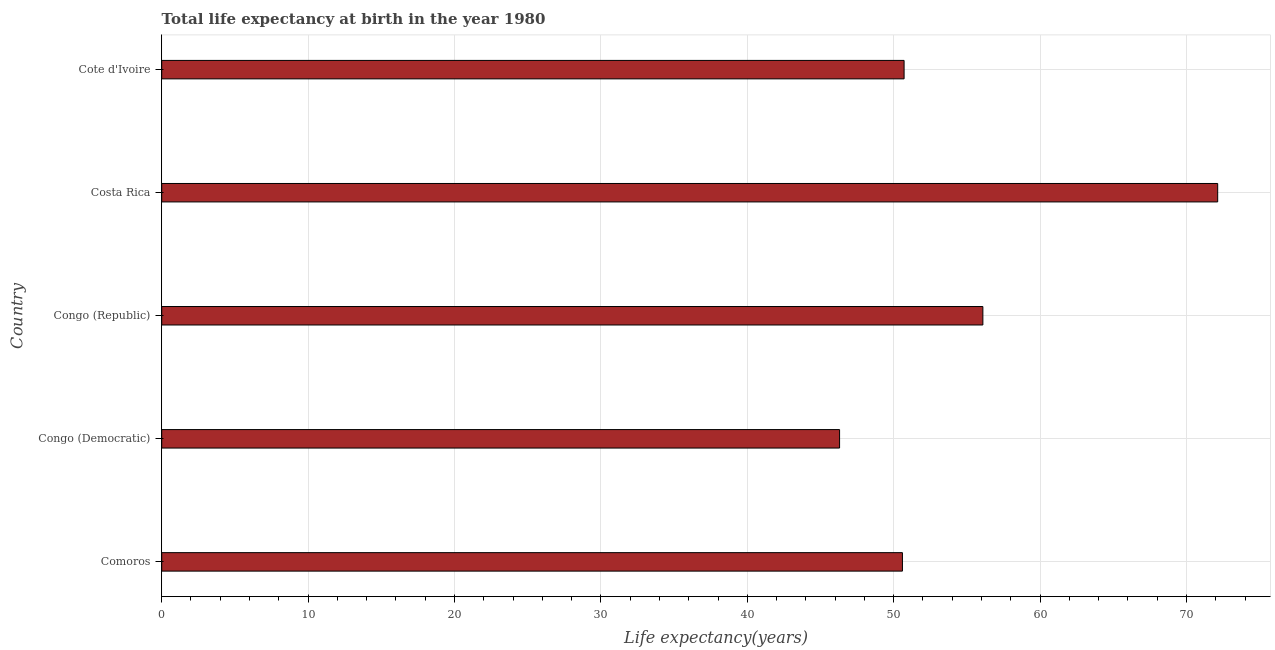What is the title of the graph?
Offer a terse response. Total life expectancy at birth in the year 1980. What is the label or title of the X-axis?
Offer a very short reply. Life expectancy(years). What is the label or title of the Y-axis?
Keep it short and to the point. Country. What is the life expectancy at birth in Congo (Republic)?
Ensure brevity in your answer.  56.09. Across all countries, what is the maximum life expectancy at birth?
Your response must be concise. 72.13. Across all countries, what is the minimum life expectancy at birth?
Offer a very short reply. 46.3. In which country was the life expectancy at birth minimum?
Your answer should be very brief. Congo (Democratic). What is the sum of the life expectancy at birth?
Offer a terse response. 275.83. What is the difference between the life expectancy at birth in Congo (Democratic) and Congo (Republic)?
Give a very brief answer. -9.79. What is the average life expectancy at birth per country?
Give a very brief answer. 55.17. What is the median life expectancy at birth?
Your answer should be very brief. 50.71. In how many countries, is the life expectancy at birth greater than 62 years?
Provide a short and direct response. 1. What is the ratio of the life expectancy at birth in Congo (Democratic) to that in Congo (Republic)?
Your response must be concise. 0.82. Is the life expectancy at birth in Comoros less than that in Congo (Democratic)?
Give a very brief answer. No. What is the difference between the highest and the second highest life expectancy at birth?
Offer a terse response. 16.04. What is the difference between the highest and the lowest life expectancy at birth?
Your answer should be compact. 25.83. In how many countries, is the life expectancy at birth greater than the average life expectancy at birth taken over all countries?
Offer a very short reply. 2. Are all the bars in the graph horizontal?
Your response must be concise. Yes. How many countries are there in the graph?
Offer a very short reply. 5. What is the difference between two consecutive major ticks on the X-axis?
Your answer should be compact. 10. What is the Life expectancy(years) of Comoros?
Offer a terse response. 50.6. What is the Life expectancy(years) in Congo (Democratic)?
Your answer should be very brief. 46.3. What is the Life expectancy(years) in Congo (Republic)?
Provide a succinct answer. 56.09. What is the Life expectancy(years) in Costa Rica?
Ensure brevity in your answer.  72.13. What is the Life expectancy(years) of Cote d'Ivoire?
Make the answer very short. 50.71. What is the difference between the Life expectancy(years) in Comoros and Congo (Democratic)?
Make the answer very short. 4.29. What is the difference between the Life expectancy(years) in Comoros and Congo (Republic)?
Your response must be concise. -5.49. What is the difference between the Life expectancy(years) in Comoros and Costa Rica?
Your response must be concise. -21.53. What is the difference between the Life expectancy(years) in Comoros and Cote d'Ivoire?
Provide a succinct answer. -0.11. What is the difference between the Life expectancy(years) in Congo (Democratic) and Congo (Republic)?
Your response must be concise. -9.79. What is the difference between the Life expectancy(years) in Congo (Democratic) and Costa Rica?
Provide a succinct answer. -25.83. What is the difference between the Life expectancy(years) in Congo (Democratic) and Cote d'Ivoire?
Offer a very short reply. -4.41. What is the difference between the Life expectancy(years) in Congo (Republic) and Costa Rica?
Ensure brevity in your answer.  -16.04. What is the difference between the Life expectancy(years) in Congo (Republic) and Cote d'Ivoire?
Keep it short and to the point. 5.38. What is the difference between the Life expectancy(years) in Costa Rica and Cote d'Ivoire?
Your answer should be very brief. 21.42. What is the ratio of the Life expectancy(years) in Comoros to that in Congo (Democratic)?
Provide a succinct answer. 1.09. What is the ratio of the Life expectancy(years) in Comoros to that in Congo (Republic)?
Keep it short and to the point. 0.9. What is the ratio of the Life expectancy(years) in Comoros to that in Costa Rica?
Your response must be concise. 0.7. What is the ratio of the Life expectancy(years) in Congo (Democratic) to that in Congo (Republic)?
Give a very brief answer. 0.82. What is the ratio of the Life expectancy(years) in Congo (Democratic) to that in Costa Rica?
Offer a terse response. 0.64. What is the ratio of the Life expectancy(years) in Congo (Democratic) to that in Cote d'Ivoire?
Your answer should be compact. 0.91. What is the ratio of the Life expectancy(years) in Congo (Republic) to that in Costa Rica?
Your response must be concise. 0.78. What is the ratio of the Life expectancy(years) in Congo (Republic) to that in Cote d'Ivoire?
Offer a terse response. 1.11. What is the ratio of the Life expectancy(years) in Costa Rica to that in Cote d'Ivoire?
Your answer should be compact. 1.42. 